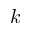<formula> <loc_0><loc_0><loc_500><loc_500>k</formula> 